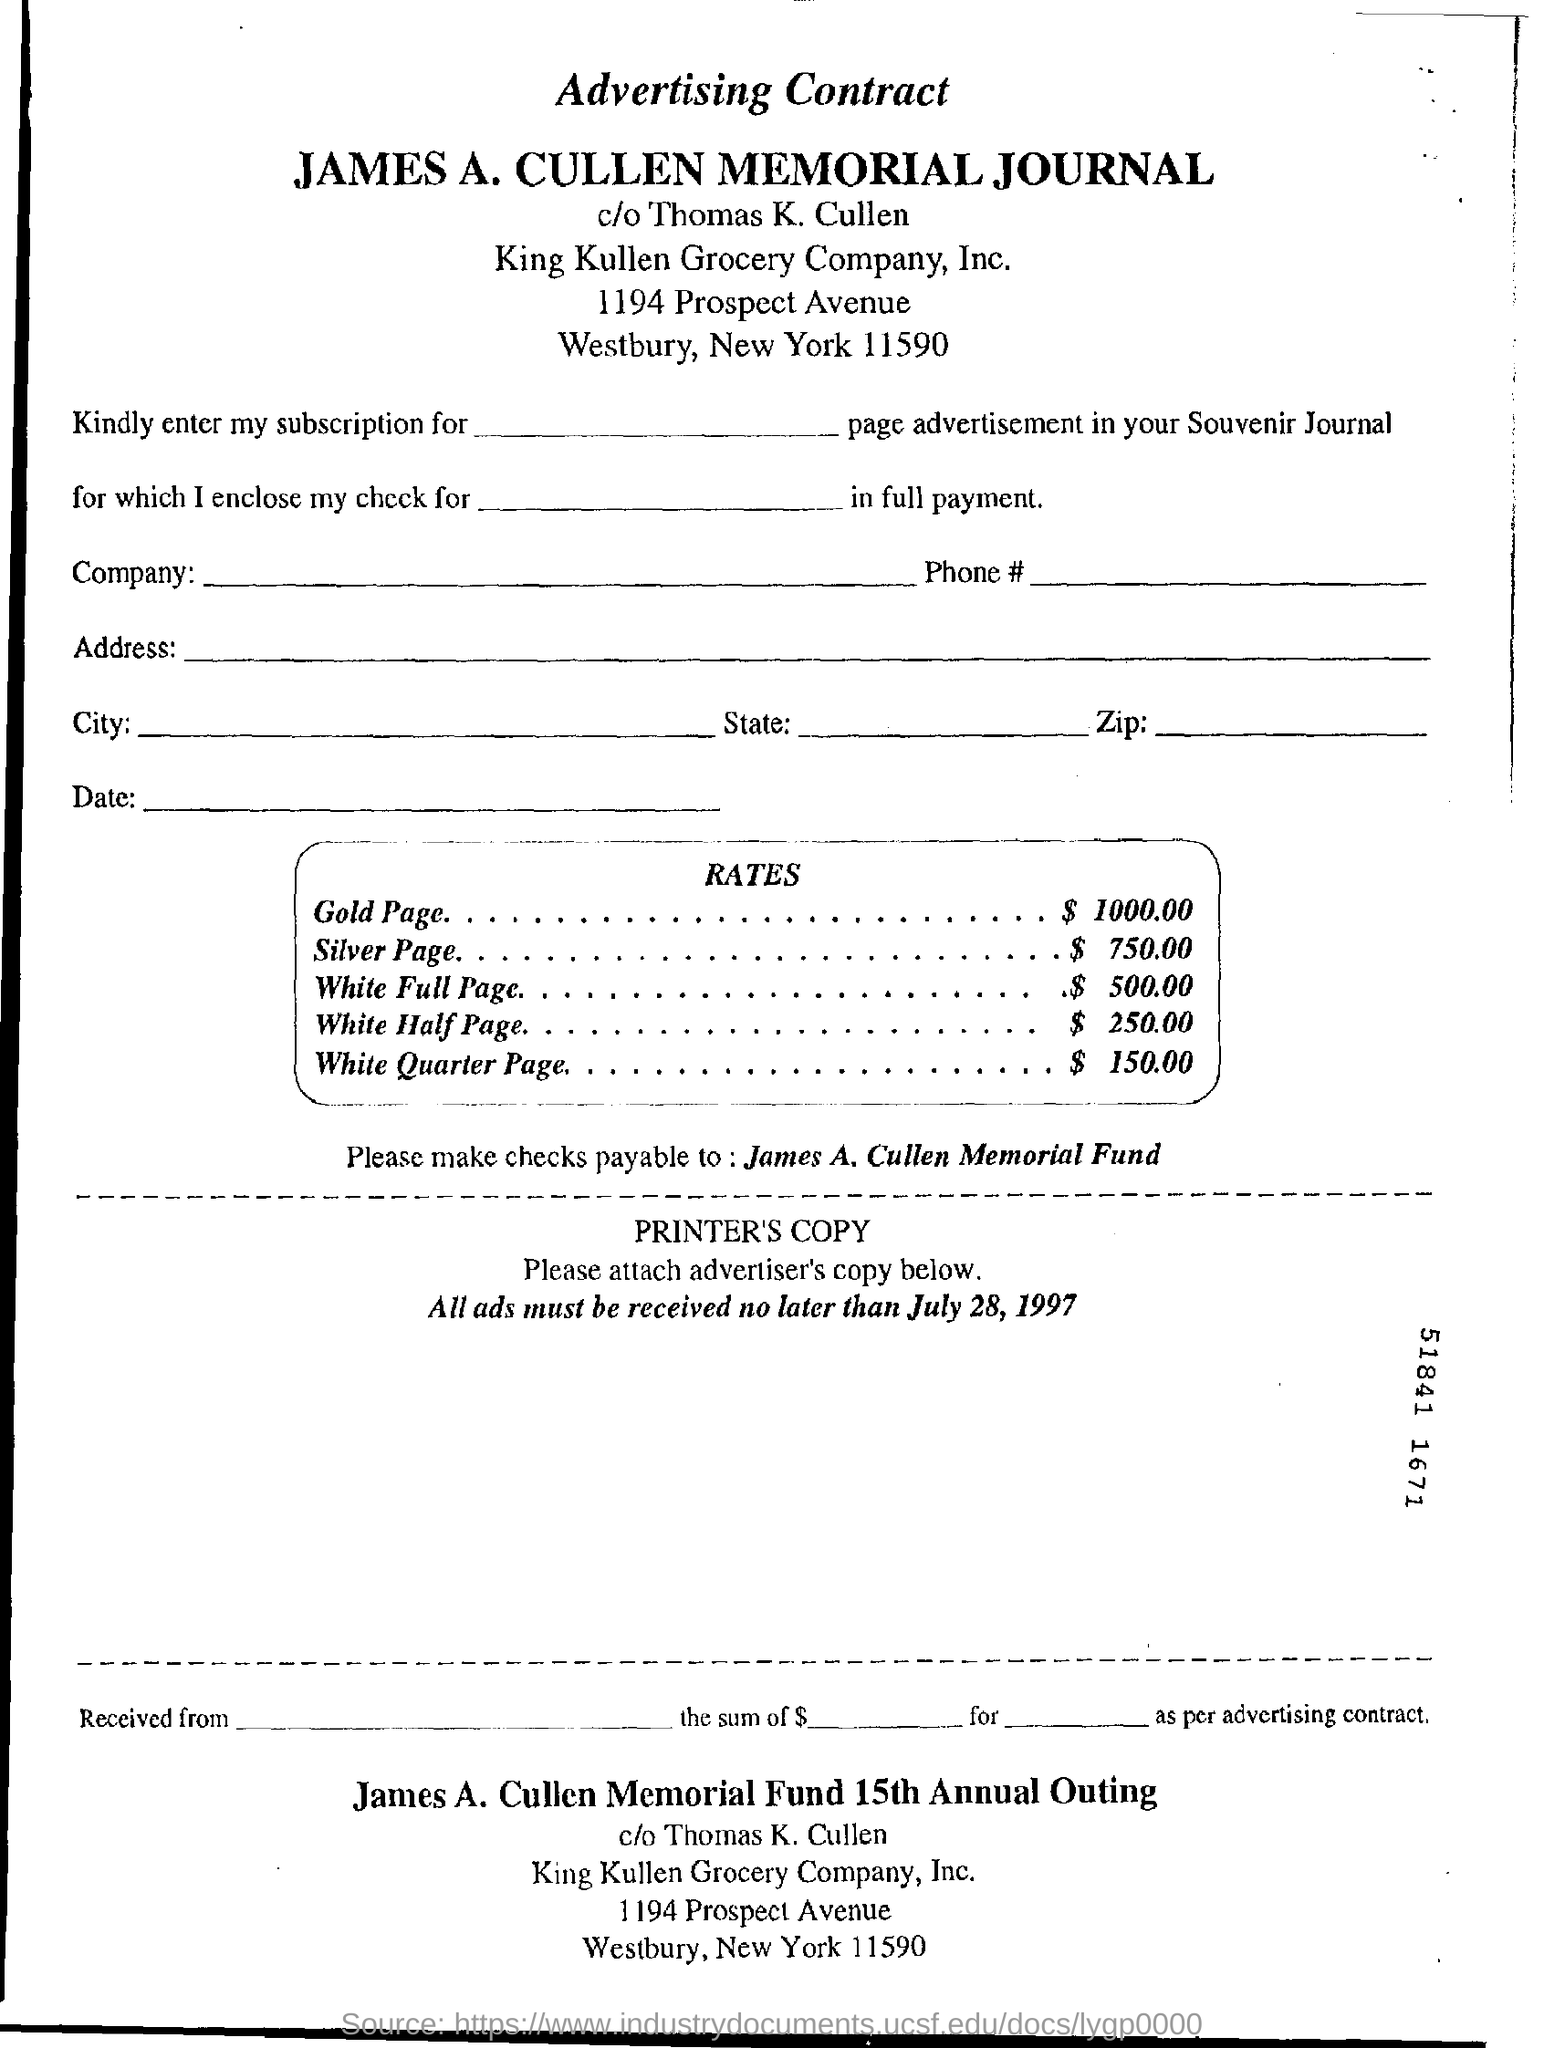What type of documentation is this?
Ensure brevity in your answer.  Advertising contract. What is the rate of gold page?
Your answer should be very brief. $1000.00. What is the rate of white half page?
Provide a short and direct response. $250.00. To whom should checks be payable?
Ensure brevity in your answer.  James A., Cullen Memorial Fund. What is the last date to receive all ads?
Provide a succinct answer. July 28,1997. 